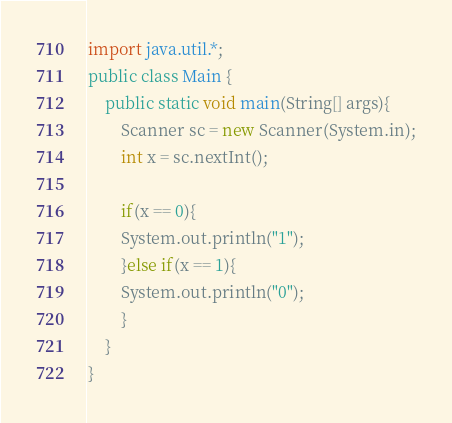<code> <loc_0><loc_0><loc_500><loc_500><_Java_>import java.util.*;
public class Main {
    public static void main(String[] args){
        Scanner sc = new Scanner(System.in);
        int x = sc.nextInt();

        if(x == 0){
        System.out.println("1");
        }else if(x == 1){
        System.out.println("0");
        }
    }
}</code> 